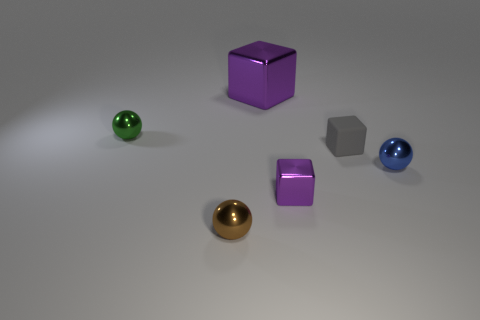Do the block that is behind the small green sphere and the metal block in front of the small green shiny ball have the same color?
Make the answer very short. Yes. What number of things are either small purple cubes or big shiny cubes?
Your response must be concise. 2. What number of other things have the same material as the blue object?
Provide a short and direct response. 4. Is the number of tiny cyan cubes less than the number of tiny blue metallic things?
Provide a short and direct response. Yes. Do the brown sphere in front of the tiny green object and the big thing have the same material?
Offer a very short reply. Yes. How many spheres are large yellow things or matte objects?
Keep it short and to the point. 0. There is a metallic thing that is both behind the tiny purple block and in front of the green sphere; what is its shape?
Offer a terse response. Sphere. There is a small metallic object behind the tiny sphere that is right of the purple metal object that is behind the small green metal sphere; what is its color?
Ensure brevity in your answer.  Green. Is the number of big objects in front of the tiny green shiny sphere less than the number of cyan shiny cylinders?
Your answer should be very brief. No. Do the tiny shiny thing behind the gray matte object and the shiny object on the right side of the tiny gray object have the same shape?
Make the answer very short. Yes. 